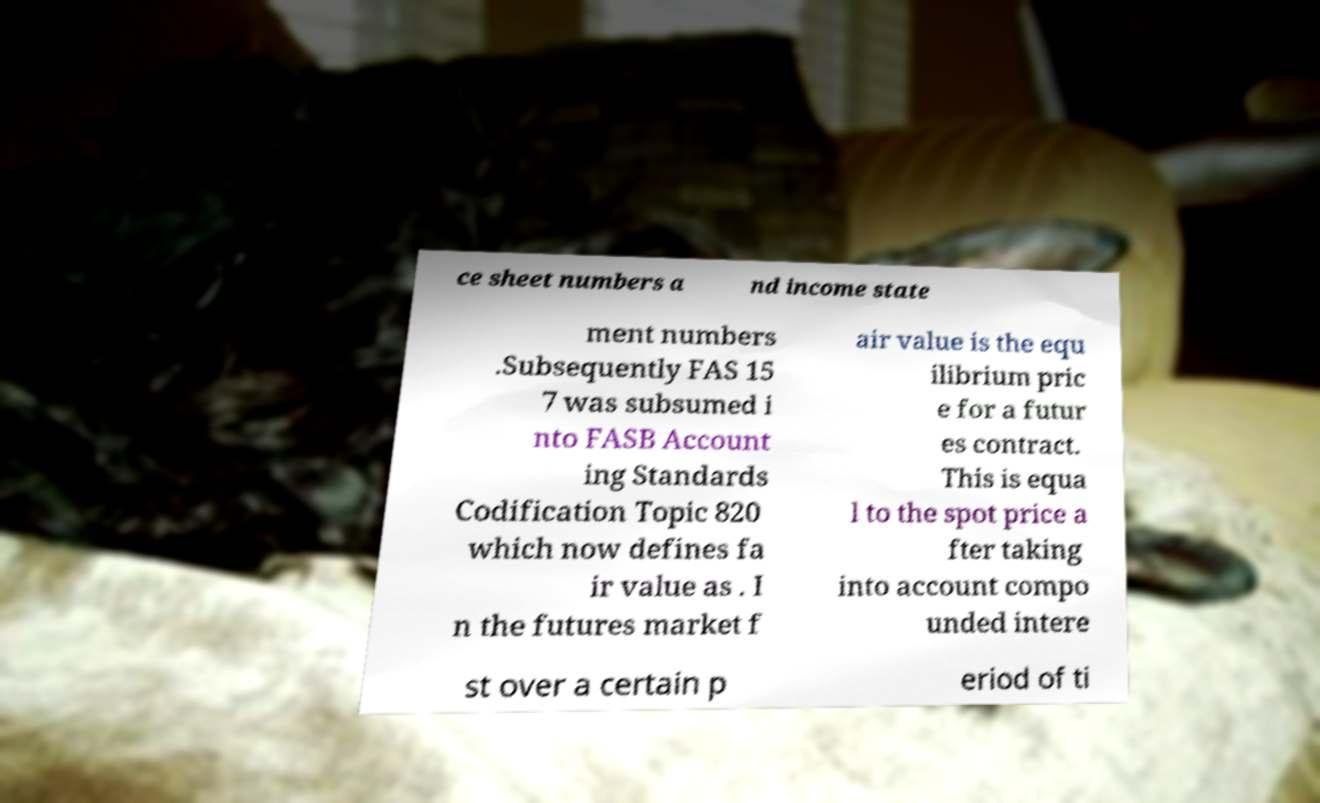I need the written content from this picture converted into text. Can you do that? ce sheet numbers a nd income state ment numbers .Subsequently FAS 15 7 was subsumed i nto FASB Account ing Standards Codification Topic 820 which now defines fa ir value as . I n the futures market f air value is the equ ilibrium pric e for a futur es contract. This is equa l to the spot price a fter taking into account compo unded intere st over a certain p eriod of ti 